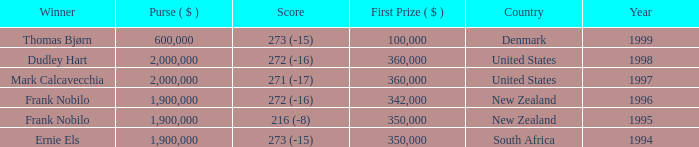What was the total purse in the years after 1996 with a score of 272 (-16) when frank nobilo won? None. 